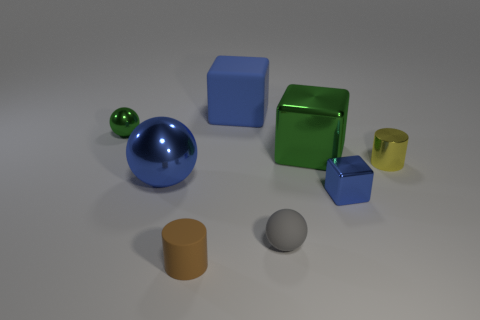Add 1 blue rubber cubes. How many objects exist? 9 Subtract all spheres. How many objects are left? 5 Add 1 tiny green balls. How many tiny green balls are left? 2 Add 3 cylinders. How many cylinders exist? 5 Subtract 0 red balls. How many objects are left? 8 Subtract all green things. Subtract all blue rubber objects. How many objects are left? 5 